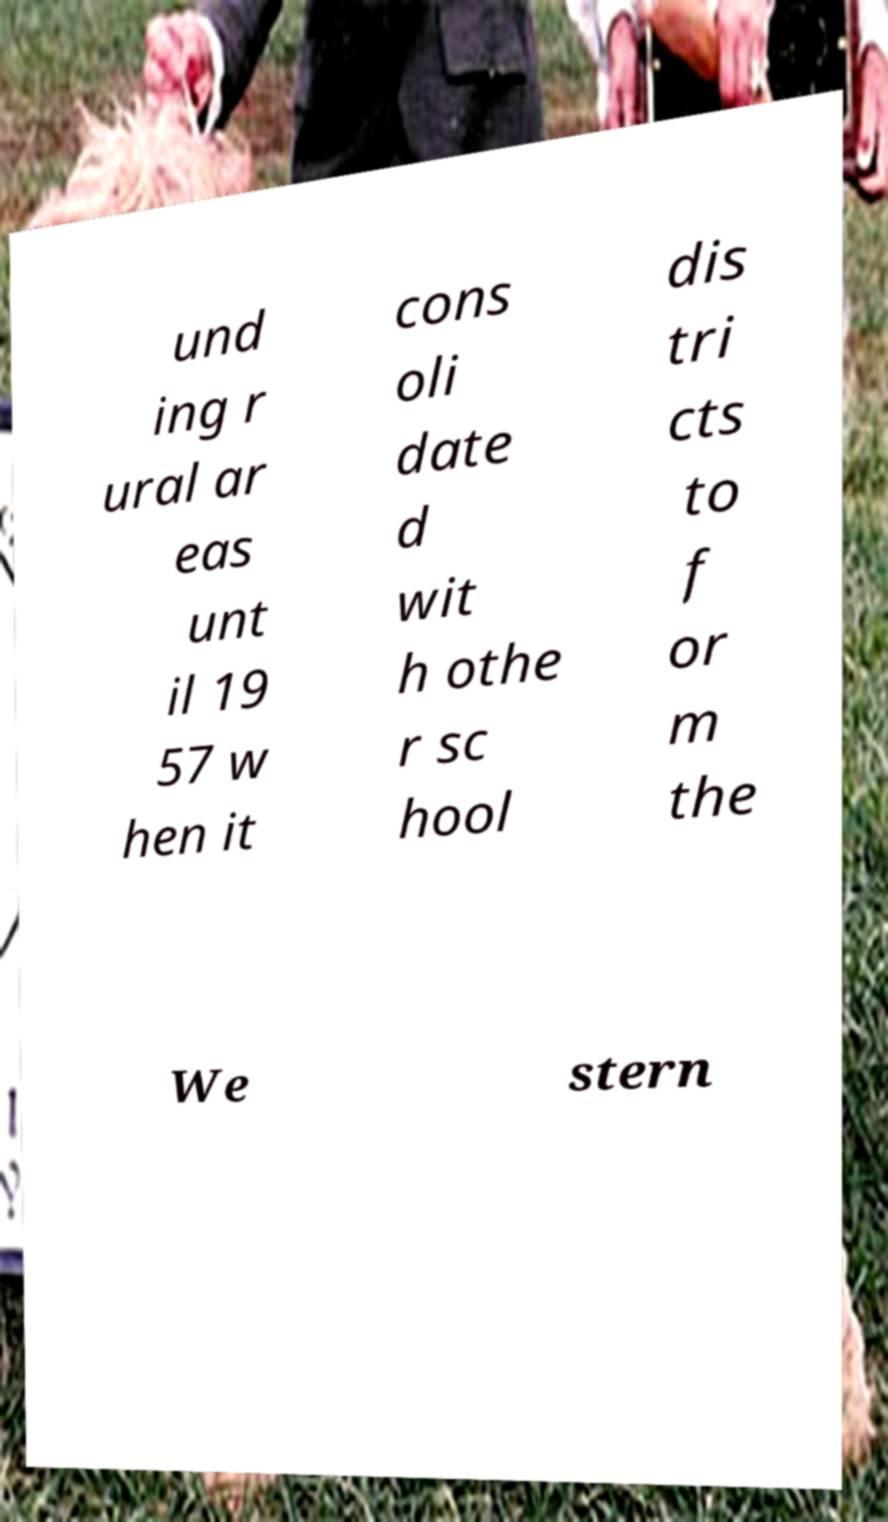Could you extract and type out the text from this image? und ing r ural ar eas unt il 19 57 w hen it cons oli date d wit h othe r sc hool dis tri cts to f or m the We stern 